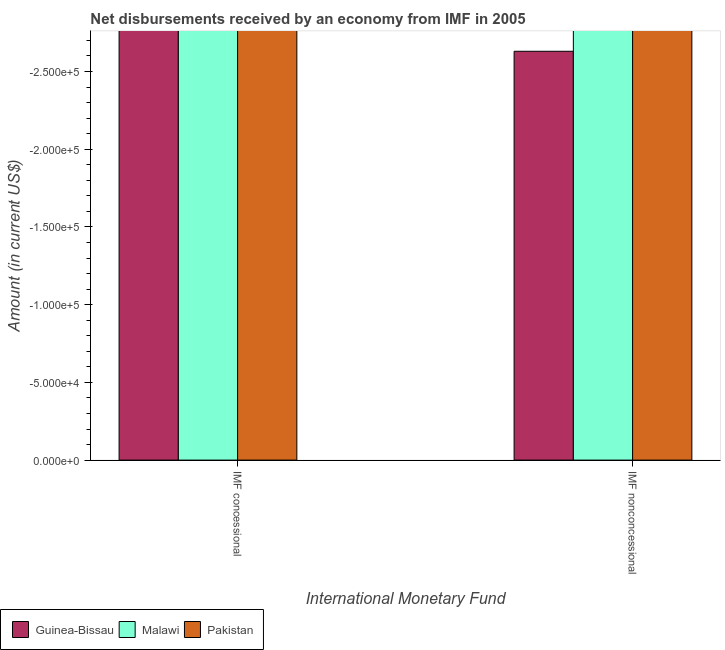How many different coloured bars are there?
Ensure brevity in your answer.  0. How many bars are there on the 1st tick from the right?
Offer a very short reply. 0. What is the label of the 1st group of bars from the left?
Give a very brief answer. IMF concessional. What is the net concessional disbursements from imf in Malawi?
Offer a very short reply. 0. Across all countries, what is the minimum net concessional disbursements from imf?
Provide a short and direct response. 0. What is the total net non concessional disbursements from imf in the graph?
Provide a short and direct response. 0. What is the average net non concessional disbursements from imf per country?
Provide a short and direct response. 0. In how many countries, is the net non concessional disbursements from imf greater than -150000 US$?
Make the answer very short. 0. In how many countries, is the net concessional disbursements from imf greater than the average net concessional disbursements from imf taken over all countries?
Offer a terse response. 0. How many bars are there?
Offer a very short reply. 0. How many countries are there in the graph?
Your response must be concise. 3. What is the difference between two consecutive major ticks on the Y-axis?
Your response must be concise. 5.00e+04. Are the values on the major ticks of Y-axis written in scientific E-notation?
Provide a short and direct response. Yes. Does the graph contain any zero values?
Offer a terse response. Yes. Where does the legend appear in the graph?
Your answer should be compact. Bottom left. What is the title of the graph?
Your answer should be very brief. Net disbursements received by an economy from IMF in 2005. Does "Monaco" appear as one of the legend labels in the graph?
Make the answer very short. No. What is the label or title of the X-axis?
Provide a succinct answer. International Monetary Fund. What is the label or title of the Y-axis?
Offer a very short reply. Amount (in current US$). What is the Amount (in current US$) of Pakistan in IMF concessional?
Your answer should be very brief. 0. What is the Amount (in current US$) of Guinea-Bissau in IMF nonconcessional?
Your answer should be very brief. 0. What is the Amount (in current US$) of Pakistan in IMF nonconcessional?
Offer a very short reply. 0. What is the total Amount (in current US$) of Malawi in the graph?
Your response must be concise. 0. 